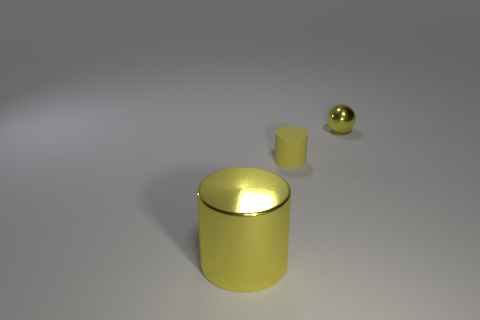Subtract all gray balls. Subtract all red blocks. How many balls are left? 1 Add 1 big shiny cylinders. How many objects exist? 4 Subtract all spheres. How many objects are left? 2 Add 1 tiny yellow metallic things. How many tiny yellow metallic things are left? 2 Add 3 yellow cylinders. How many yellow cylinders exist? 5 Subtract 1 yellow spheres. How many objects are left? 2 Subtract all tiny cyan shiny cylinders. Subtract all big yellow objects. How many objects are left? 2 